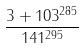Convert formula to latex. <formula><loc_0><loc_0><loc_500><loc_500>\frac { 3 + 1 0 3 ^ { 2 8 5 } } { 1 4 1 ^ { 2 9 5 } }</formula> 